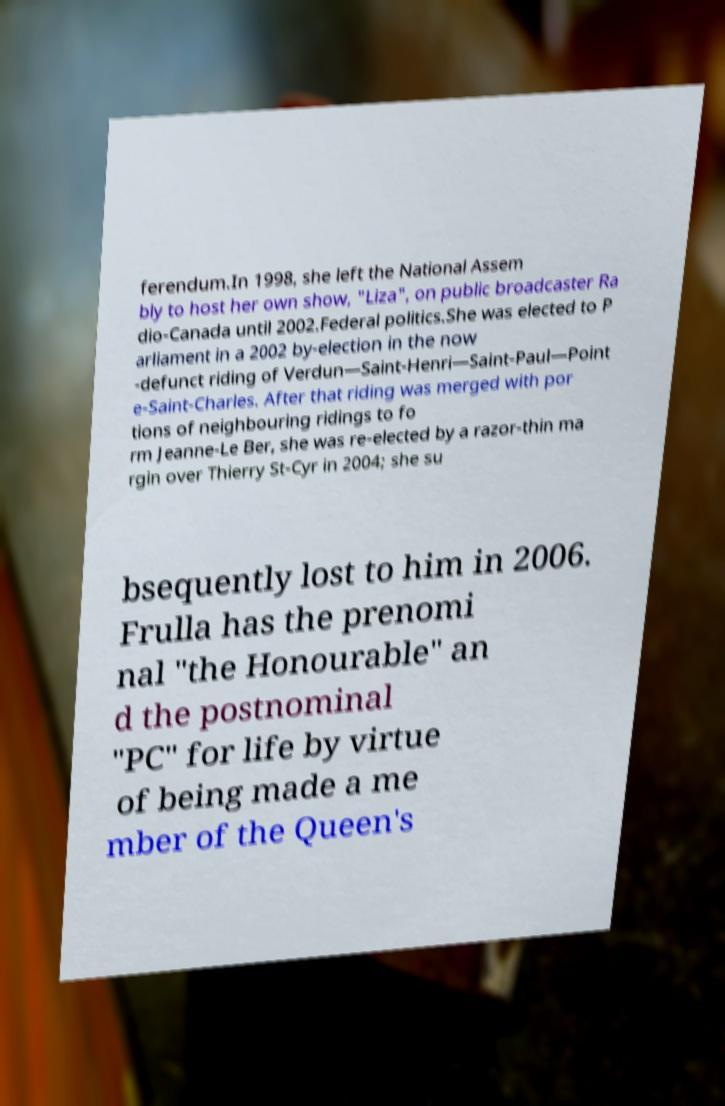Could you extract and type out the text from this image? ferendum.In 1998, she left the National Assem bly to host her own show, "Liza", on public broadcaster Ra dio-Canada until 2002.Federal politics.She was elected to P arliament in a 2002 by-election in the now -defunct riding of Verdun—Saint-Henri—Saint-Paul—Point e-Saint-Charles. After that riding was merged with por tions of neighbouring ridings to fo rm Jeanne-Le Ber, she was re-elected by a razor-thin ma rgin over Thierry St-Cyr in 2004; she su bsequently lost to him in 2006. Frulla has the prenomi nal "the Honourable" an d the postnominal "PC" for life by virtue of being made a me mber of the Queen's 